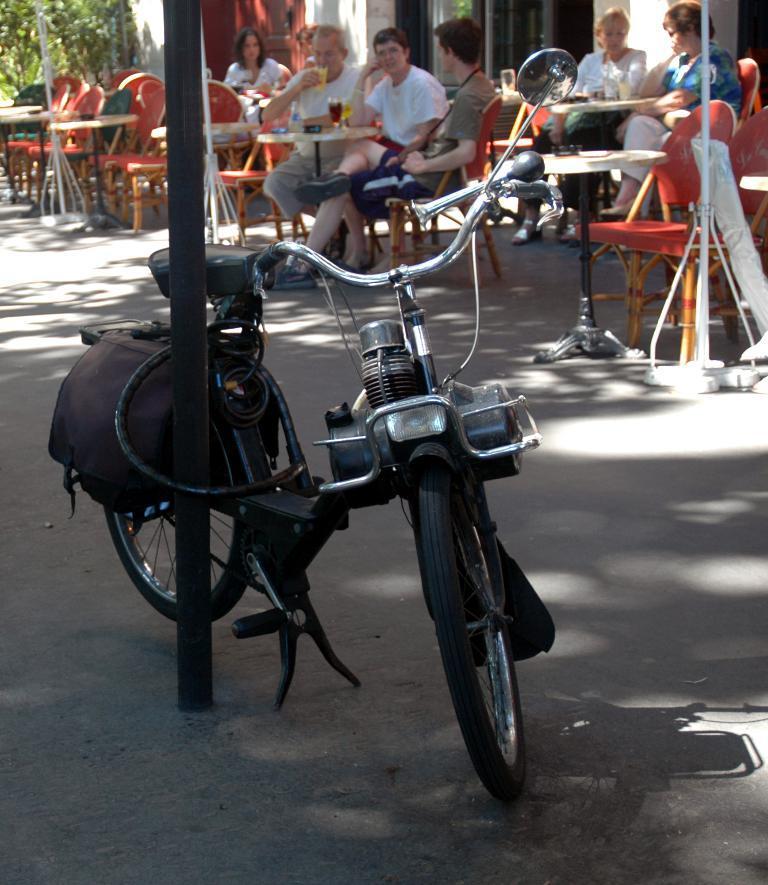In one or two sentences, can you explain what this image depicts? As we can see in the image there are few people, tables, chairs and a building. On the left side background there is a tree. In the front there is bicycle. 